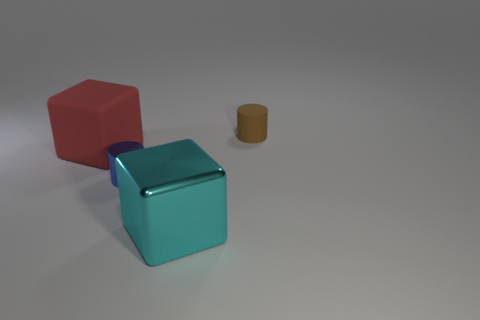What materials do these objects seem to be made from? The objects in the image depict a red block, a teal block, and a brown cylinder with a matte finish, suggesting they could be made from a plastic or painted wood material. Could you describe the lighting in the scene? The lighting appears to come from above, casting soft, diffused shadows to the lower right of the objects, which suggests an indoor setting with ambient light sources. 